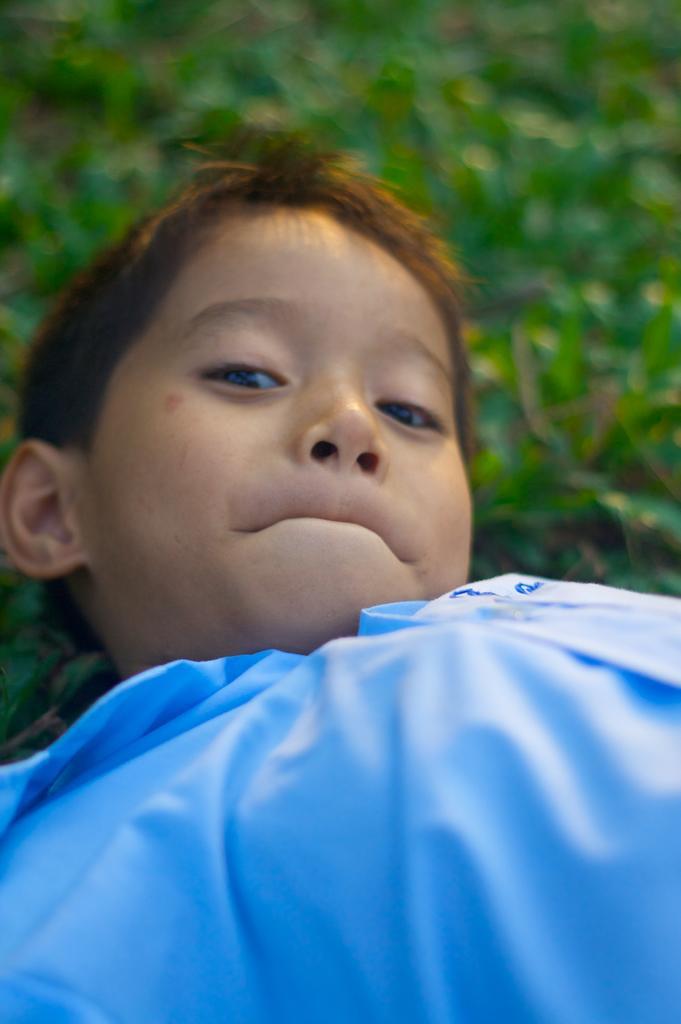In one or two sentences, can you explain what this image depicts? In this picture there is a boy wore shirt. In the background of the image it is blurry. 